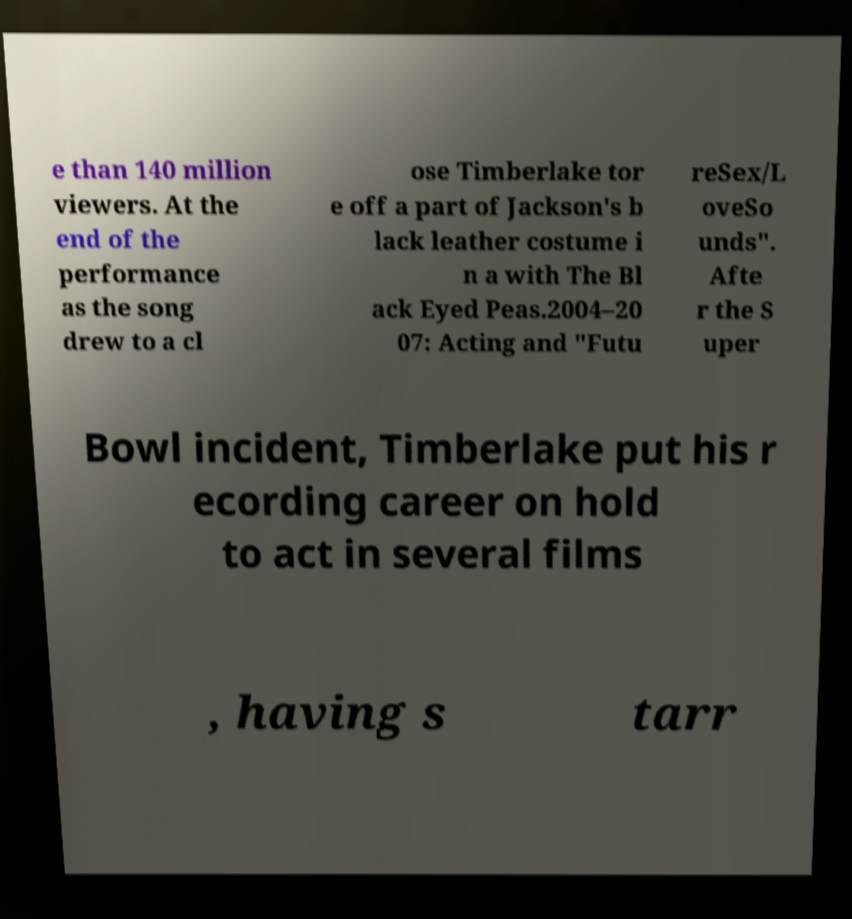There's text embedded in this image that I need extracted. Can you transcribe it verbatim? e than 140 million viewers. At the end of the performance as the song drew to a cl ose Timberlake tor e off a part of Jackson's b lack leather costume i n a with The Bl ack Eyed Peas.2004–20 07: Acting and "Futu reSex/L oveSo unds". Afte r the S uper Bowl incident, Timberlake put his r ecording career on hold to act in several films , having s tarr 